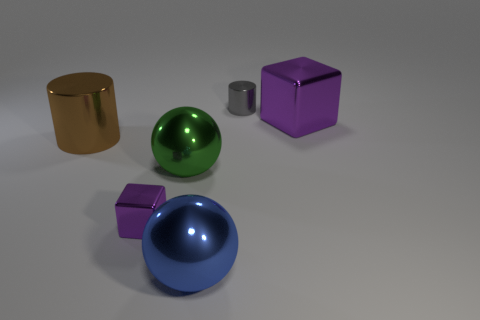Add 4 purple shiny things. How many objects exist? 10 Subtract all cubes. How many objects are left? 4 Subtract all gray shiny cylinders. Subtract all small purple metallic objects. How many objects are left? 4 Add 5 tiny gray metal objects. How many tiny gray metal objects are left? 6 Add 2 large yellow matte balls. How many large yellow matte balls exist? 2 Subtract 0 brown balls. How many objects are left? 6 